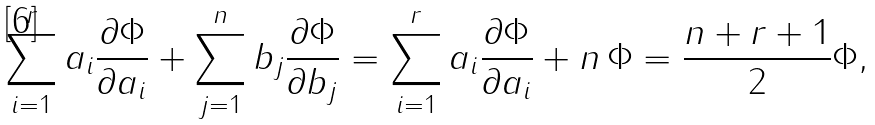<formula> <loc_0><loc_0><loc_500><loc_500>\sum _ { i = 1 } ^ { r } a _ { i } \frac { \partial \Phi } { \partial a _ { i } } + \sum _ { j = 1 } ^ { n } b _ { j } \frac { \partial \Phi } { \partial b _ { j } } = \sum _ { i = 1 } ^ { r } a _ { i } \frac { \partial \Phi } { \partial a _ { i } } + n \, \Phi = \frac { n + r + 1 } { 2 } \Phi ,</formula> 